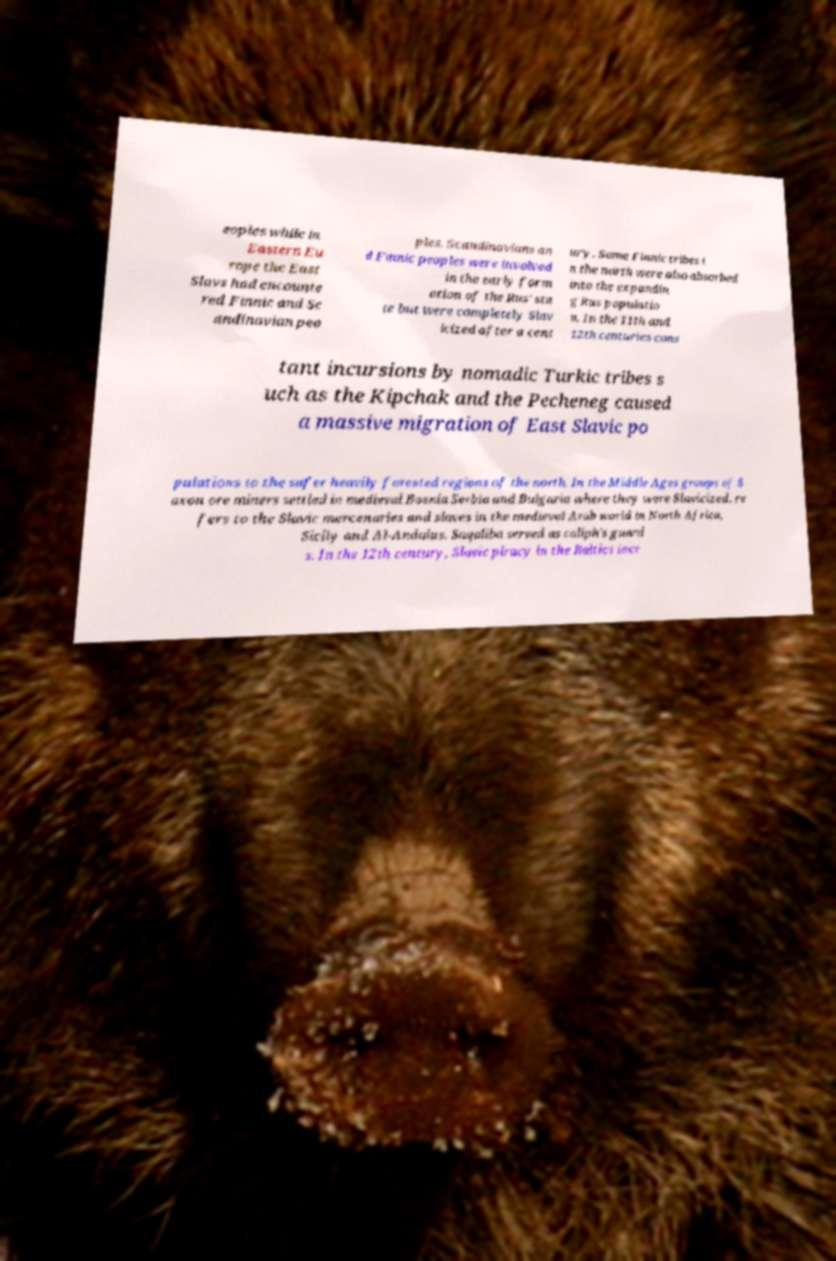Could you assist in decoding the text presented in this image and type it out clearly? eoples while in Eastern Eu rope the East Slavs had encounte red Finnic and Sc andinavian peo ples. Scandinavians an d Finnic peoples were involved in the early form ation of the Rus' sta te but were completely Slav icized after a cent ury. Some Finnic tribes i n the north were also absorbed into the expandin g Rus populatio n. In the 11th and 12th centuries cons tant incursions by nomadic Turkic tribes s uch as the Kipchak and the Pecheneg caused a massive migration of East Slavic po pulations to the safer heavily forested regions of the north. In the Middle Ages groups of S axon ore miners settled in medieval Bosnia Serbia and Bulgaria where they were Slavicized. re fers to the Slavic mercenaries and slaves in the medieval Arab world in North Africa, Sicily and Al-Andalus. Saqaliba served as caliph's guard s. In the 12th century, Slavic piracy in the Baltics incr 